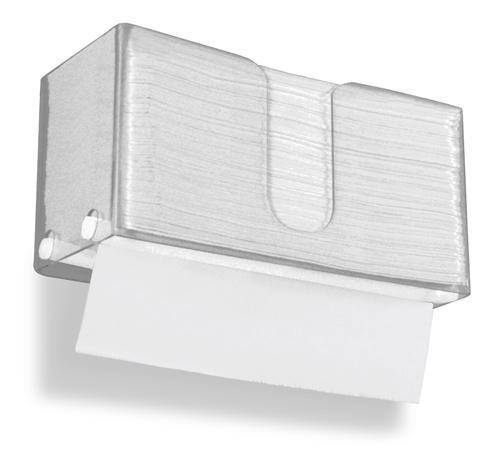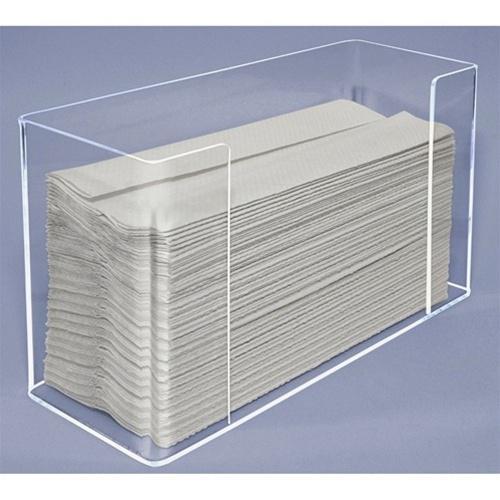The first image is the image on the left, the second image is the image on the right. Analyze the images presented: Is the assertion "A clear paper towel holder is full and has one towel hanging out the bottom." valid? Answer yes or no. Yes. The first image is the image on the left, the second image is the image on the right. Given the left and right images, does the statement "In at least one image there is a clear plastic paper towel holder with the white paper towel coming out the bottom." hold true? Answer yes or no. Yes. 